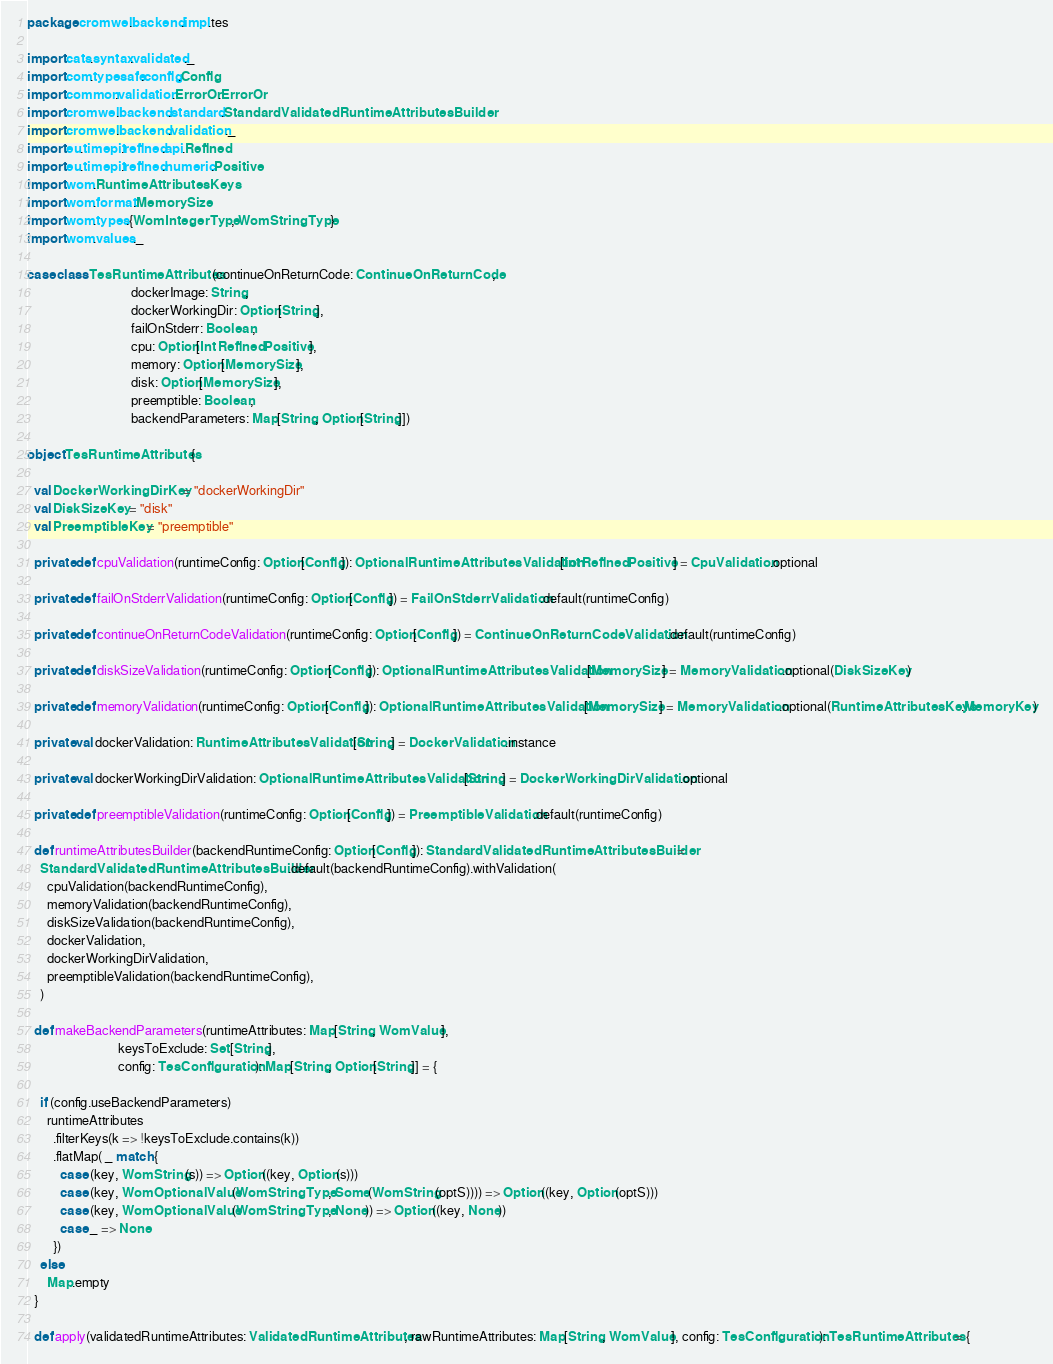<code> <loc_0><loc_0><loc_500><loc_500><_Scala_>package cromwell.backend.impl.tes

import cats.syntax.validated._
import com.typesafe.config.Config
import common.validation.ErrorOr.ErrorOr
import cromwell.backend.standard.StandardValidatedRuntimeAttributesBuilder
import cromwell.backend.validation._
import eu.timepit.refined.api.Refined
import eu.timepit.refined.numeric.Positive
import wom.RuntimeAttributesKeys
import wom.format.MemorySize
import wom.types.{WomIntegerType, WomStringType}
import wom.values._

case class TesRuntimeAttributes(continueOnReturnCode: ContinueOnReturnCode,
                                dockerImage: String,
                                dockerWorkingDir: Option[String],
                                failOnStderr: Boolean,
                                cpu: Option[Int Refined Positive],
                                memory: Option[MemorySize],
                                disk: Option[MemorySize],
                                preemptible: Boolean,
                                backendParameters: Map[String, Option[String]])

object TesRuntimeAttributes {

  val DockerWorkingDirKey = "dockerWorkingDir"
  val DiskSizeKey = "disk"
  val PreemptibleKey = "preemptible"

  private def cpuValidation(runtimeConfig: Option[Config]): OptionalRuntimeAttributesValidation[Int Refined Positive] = CpuValidation.optional

  private def failOnStderrValidation(runtimeConfig: Option[Config]) = FailOnStderrValidation.default(runtimeConfig)

  private def continueOnReturnCodeValidation(runtimeConfig: Option[Config]) = ContinueOnReturnCodeValidation.default(runtimeConfig)

  private def diskSizeValidation(runtimeConfig: Option[Config]): OptionalRuntimeAttributesValidation[MemorySize] = MemoryValidation.optional(DiskSizeKey)

  private def memoryValidation(runtimeConfig: Option[Config]): OptionalRuntimeAttributesValidation[MemorySize] = MemoryValidation.optional(RuntimeAttributesKeys.MemoryKey)

  private val dockerValidation: RuntimeAttributesValidation[String] = DockerValidation.instance

  private val dockerWorkingDirValidation: OptionalRuntimeAttributesValidation[String] = DockerWorkingDirValidation.optional

  private def preemptibleValidation(runtimeConfig: Option[Config]) = PreemptibleValidation.default(runtimeConfig)

  def runtimeAttributesBuilder(backendRuntimeConfig: Option[Config]): StandardValidatedRuntimeAttributesBuilder =
    StandardValidatedRuntimeAttributesBuilder.default(backendRuntimeConfig).withValidation(
      cpuValidation(backendRuntimeConfig),
      memoryValidation(backendRuntimeConfig),
      diskSizeValidation(backendRuntimeConfig),
      dockerValidation,
      dockerWorkingDirValidation,
      preemptibleValidation(backendRuntimeConfig),
    )

  def makeBackendParameters(runtimeAttributes: Map[String, WomValue],
                            keysToExclude: Set[String],
                            config: TesConfiguration): Map[String, Option[String]] = {

    if (config.useBackendParameters)
      runtimeAttributes
        .filterKeys(k => !keysToExclude.contains(k))
        .flatMap( _ match {
          case (key, WomString(s)) => Option((key, Option(s)))
          case (key, WomOptionalValue(WomStringType, Some(WomString(optS)))) => Option((key, Option(optS)))
          case (key, WomOptionalValue(WomStringType, None)) => Option((key, None))
          case _ => None
        })
    else
      Map.empty
  }

  def apply(validatedRuntimeAttributes: ValidatedRuntimeAttributes, rawRuntimeAttributes: Map[String, WomValue], config: TesConfiguration): TesRuntimeAttributes = {</code> 